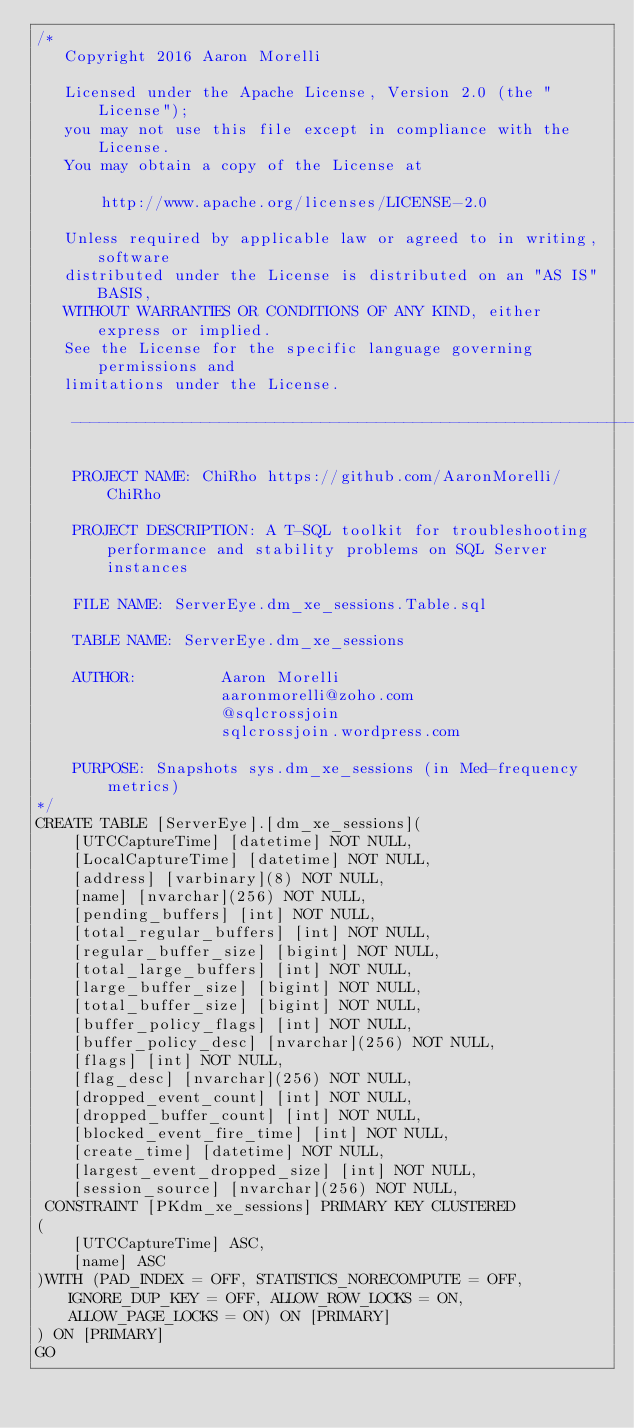<code> <loc_0><loc_0><loc_500><loc_500><_SQL_>/*
   Copyright 2016 Aaron Morelli

   Licensed under the Apache License, Version 2.0 (the "License");
   you may not use this file except in compliance with the License.
   You may obtain a copy of the License at

       http://www.apache.org/licenses/LICENSE-2.0

   Unless required by applicable law or agreed to in writing, software
   distributed under the License is distributed on an "AS IS" BASIS,
   WITHOUT WARRANTIES OR CONDITIONS OF ANY KIND, either express or implied.
   See the License for the specific language governing permissions and
   limitations under the License.

	------------------------------------------------------------------------

	PROJECT NAME: ChiRho https://github.com/AaronMorelli/ChiRho

	PROJECT DESCRIPTION: A T-SQL toolkit for troubleshooting performance and stability problems on SQL Server instances

	FILE NAME: ServerEye.dm_xe_sessions.Table.sql

	TABLE NAME: ServerEye.dm_xe_sessions

	AUTHOR:			Aaron Morelli
					aaronmorelli@zoho.com
					@sqlcrossjoin
					sqlcrossjoin.wordpress.com

	PURPOSE: Snapshots sys.dm_xe_sessions (in Med-frequency metrics)
*/
CREATE TABLE [ServerEye].[dm_xe_sessions](
	[UTCCaptureTime] [datetime] NOT NULL,
	[LocalCaptureTime] [datetime] NOT NULL,
	[address] [varbinary](8) NOT NULL,
	[name] [nvarchar](256) NOT NULL,
	[pending_buffers] [int] NOT NULL,
	[total_regular_buffers] [int] NOT NULL,
	[regular_buffer_size] [bigint] NOT NULL,
	[total_large_buffers] [int] NOT NULL,
	[large_buffer_size] [bigint] NOT NULL,
	[total_buffer_size] [bigint] NOT NULL,
	[buffer_policy_flags] [int] NOT NULL,
	[buffer_policy_desc] [nvarchar](256) NOT NULL,
	[flags] [int] NOT NULL,
	[flag_desc] [nvarchar](256) NOT NULL,
	[dropped_event_count] [int] NOT NULL,
	[dropped_buffer_count] [int] NOT NULL,
	[blocked_event_fire_time] [int] NOT NULL,
	[create_time] [datetime] NOT NULL,
	[largest_event_dropped_size] [int] NOT NULL,
	[session_source] [nvarchar](256) NOT NULL,
 CONSTRAINT [PKdm_xe_sessions] PRIMARY KEY CLUSTERED 
(
	[UTCCaptureTime] ASC,
	[name] ASC
)WITH (PAD_INDEX = OFF, STATISTICS_NORECOMPUTE = OFF, IGNORE_DUP_KEY = OFF, ALLOW_ROW_LOCKS = ON, ALLOW_PAGE_LOCKS = ON) ON [PRIMARY]
) ON [PRIMARY]
GO</code> 